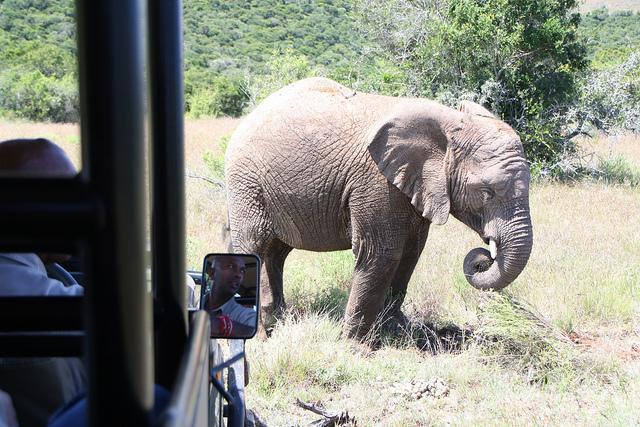What type of vehicle is the man on the left most likely riding in?
Choose the correct response and explain in the format: 'Answer: answer
Rationale: rationale.'
Options: Jeep, sedan, tour bus, convertible. Answer: jeep.
Rationale: The vehicle appears to be on uneven ground which would most likely be driven on in a jeep. 